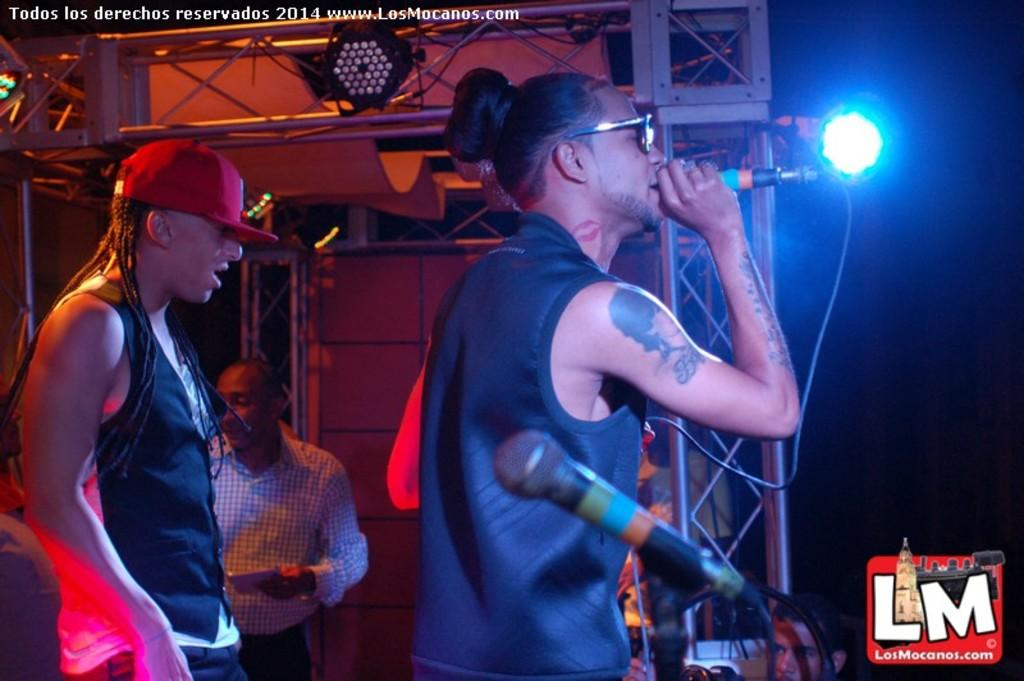What is the main activity happening in the image? There is a person performing a musical show in the image. What object is the person holding while performing? The person is holding a microphone in his hand. Can you describe the people in the background of the image? In the background, there are people dressed in black. What type of trail can be seen in the background of the image? There is no trail visible in the image; it features a person performing a musical show with people dressed in black in the background. 